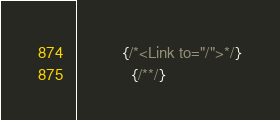Convert code to text. <code><loc_0><loc_0><loc_500><loc_500><_JavaScript_>
          {/*<Link to="/">*/}
            {/**/}</code> 